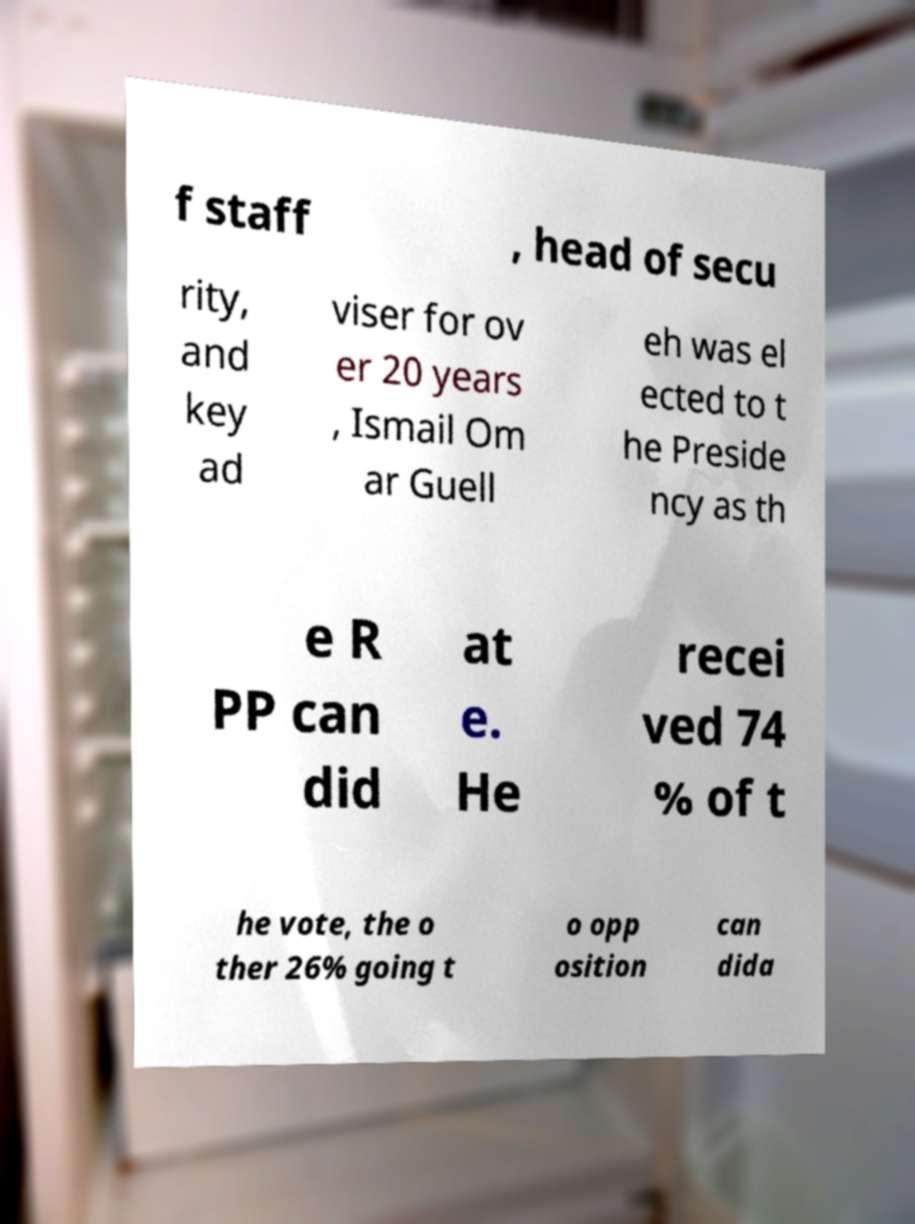For documentation purposes, I need the text within this image transcribed. Could you provide that? f staff , head of secu rity, and key ad viser for ov er 20 years , Ismail Om ar Guell eh was el ected to t he Preside ncy as th e R PP can did at e. He recei ved 74 % of t he vote, the o ther 26% going t o opp osition can dida 